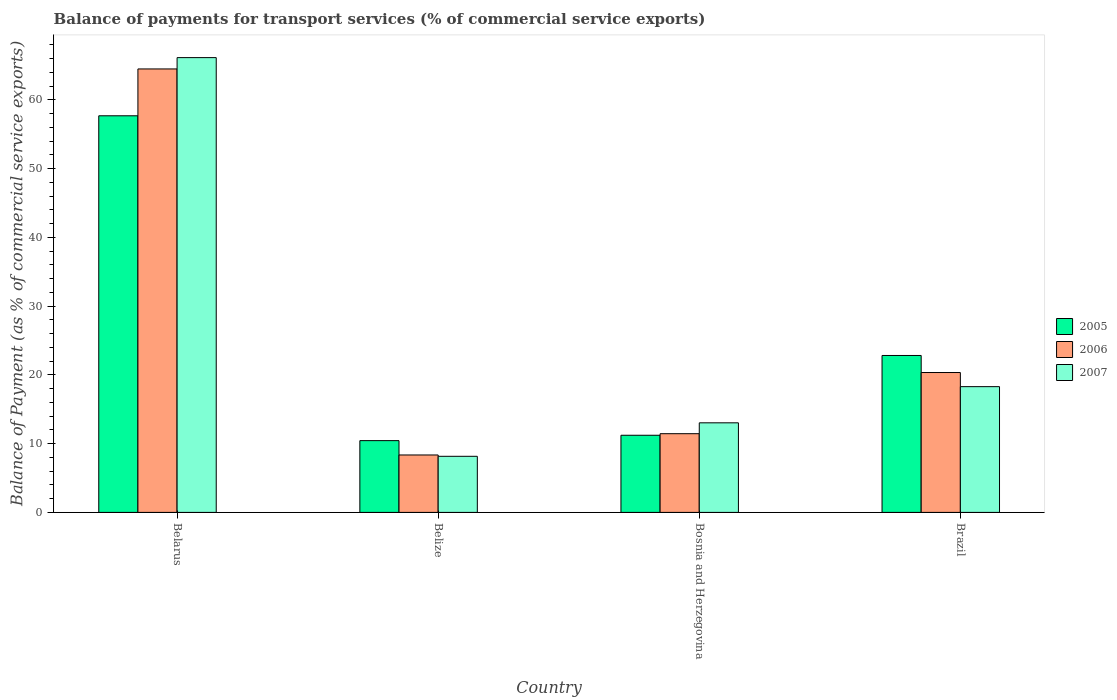How many different coloured bars are there?
Ensure brevity in your answer.  3. How many groups of bars are there?
Offer a very short reply. 4. Are the number of bars per tick equal to the number of legend labels?
Make the answer very short. Yes. Are the number of bars on each tick of the X-axis equal?
Your answer should be very brief. Yes. How many bars are there on the 4th tick from the left?
Your answer should be very brief. 3. What is the label of the 2nd group of bars from the left?
Make the answer very short. Belize. In how many cases, is the number of bars for a given country not equal to the number of legend labels?
Offer a terse response. 0. What is the balance of payments for transport services in 2007 in Belarus?
Offer a terse response. 66.15. Across all countries, what is the maximum balance of payments for transport services in 2007?
Provide a short and direct response. 66.15. Across all countries, what is the minimum balance of payments for transport services in 2005?
Provide a short and direct response. 10.44. In which country was the balance of payments for transport services in 2007 maximum?
Offer a terse response. Belarus. In which country was the balance of payments for transport services in 2007 minimum?
Offer a very short reply. Belize. What is the total balance of payments for transport services in 2005 in the graph?
Give a very brief answer. 102.18. What is the difference between the balance of payments for transport services in 2007 in Belarus and that in Brazil?
Your answer should be compact. 47.86. What is the difference between the balance of payments for transport services in 2007 in Bosnia and Herzegovina and the balance of payments for transport services in 2005 in Belarus?
Your answer should be compact. -44.66. What is the average balance of payments for transport services in 2006 per country?
Make the answer very short. 26.16. What is the difference between the balance of payments for transport services of/in 2007 and balance of payments for transport services of/in 2005 in Belize?
Your answer should be compact. -2.28. What is the ratio of the balance of payments for transport services in 2006 in Belarus to that in Bosnia and Herzegovina?
Offer a terse response. 5.63. What is the difference between the highest and the second highest balance of payments for transport services in 2005?
Offer a very short reply. 46.47. What is the difference between the highest and the lowest balance of payments for transport services in 2007?
Keep it short and to the point. 58. Is the sum of the balance of payments for transport services in 2006 in Bosnia and Herzegovina and Brazil greater than the maximum balance of payments for transport services in 2007 across all countries?
Provide a short and direct response. No. What does the 3rd bar from the left in Brazil represents?
Ensure brevity in your answer.  2007. How many bars are there?
Offer a very short reply. 12. Are all the bars in the graph horizontal?
Provide a succinct answer. No. How many countries are there in the graph?
Your answer should be very brief. 4. What is the difference between two consecutive major ticks on the Y-axis?
Provide a short and direct response. 10. Does the graph contain any zero values?
Offer a terse response. No. Does the graph contain grids?
Offer a very short reply. No. How many legend labels are there?
Give a very brief answer. 3. How are the legend labels stacked?
Your answer should be very brief. Vertical. What is the title of the graph?
Provide a short and direct response. Balance of payments for transport services (% of commercial service exports). Does "1978" appear as one of the legend labels in the graph?
Provide a succinct answer. No. What is the label or title of the Y-axis?
Give a very brief answer. Balance of Payment (as % of commercial service exports). What is the Balance of Payment (as % of commercial service exports) of 2005 in Belarus?
Give a very brief answer. 57.69. What is the Balance of Payment (as % of commercial service exports) of 2006 in Belarus?
Keep it short and to the point. 64.51. What is the Balance of Payment (as % of commercial service exports) in 2007 in Belarus?
Give a very brief answer. 66.15. What is the Balance of Payment (as % of commercial service exports) of 2005 in Belize?
Make the answer very short. 10.44. What is the Balance of Payment (as % of commercial service exports) of 2006 in Belize?
Keep it short and to the point. 8.35. What is the Balance of Payment (as % of commercial service exports) in 2007 in Belize?
Keep it short and to the point. 8.16. What is the Balance of Payment (as % of commercial service exports) in 2005 in Bosnia and Herzegovina?
Make the answer very short. 11.22. What is the Balance of Payment (as % of commercial service exports) in 2006 in Bosnia and Herzegovina?
Give a very brief answer. 11.45. What is the Balance of Payment (as % of commercial service exports) of 2007 in Bosnia and Herzegovina?
Ensure brevity in your answer.  13.03. What is the Balance of Payment (as % of commercial service exports) in 2005 in Brazil?
Provide a short and direct response. 22.83. What is the Balance of Payment (as % of commercial service exports) of 2006 in Brazil?
Give a very brief answer. 20.35. What is the Balance of Payment (as % of commercial service exports) of 2007 in Brazil?
Your answer should be very brief. 18.29. Across all countries, what is the maximum Balance of Payment (as % of commercial service exports) of 2005?
Your answer should be very brief. 57.69. Across all countries, what is the maximum Balance of Payment (as % of commercial service exports) in 2006?
Provide a short and direct response. 64.51. Across all countries, what is the maximum Balance of Payment (as % of commercial service exports) in 2007?
Your answer should be compact. 66.15. Across all countries, what is the minimum Balance of Payment (as % of commercial service exports) in 2005?
Offer a terse response. 10.44. Across all countries, what is the minimum Balance of Payment (as % of commercial service exports) of 2006?
Your answer should be very brief. 8.35. Across all countries, what is the minimum Balance of Payment (as % of commercial service exports) in 2007?
Give a very brief answer. 8.16. What is the total Balance of Payment (as % of commercial service exports) of 2005 in the graph?
Your response must be concise. 102.18. What is the total Balance of Payment (as % of commercial service exports) of 2006 in the graph?
Your answer should be very brief. 104.65. What is the total Balance of Payment (as % of commercial service exports) in 2007 in the graph?
Offer a very short reply. 105.63. What is the difference between the Balance of Payment (as % of commercial service exports) of 2005 in Belarus and that in Belize?
Your answer should be compact. 47.25. What is the difference between the Balance of Payment (as % of commercial service exports) in 2006 in Belarus and that in Belize?
Your answer should be very brief. 56.15. What is the difference between the Balance of Payment (as % of commercial service exports) of 2007 in Belarus and that in Belize?
Make the answer very short. 58. What is the difference between the Balance of Payment (as % of commercial service exports) in 2005 in Belarus and that in Bosnia and Herzegovina?
Provide a succinct answer. 46.47. What is the difference between the Balance of Payment (as % of commercial service exports) in 2006 in Belarus and that in Bosnia and Herzegovina?
Your answer should be very brief. 53.06. What is the difference between the Balance of Payment (as % of commercial service exports) in 2007 in Belarus and that in Bosnia and Herzegovina?
Provide a short and direct response. 53.12. What is the difference between the Balance of Payment (as % of commercial service exports) in 2005 in Belarus and that in Brazil?
Ensure brevity in your answer.  34.86. What is the difference between the Balance of Payment (as % of commercial service exports) in 2006 in Belarus and that in Brazil?
Ensure brevity in your answer.  44.16. What is the difference between the Balance of Payment (as % of commercial service exports) of 2007 in Belarus and that in Brazil?
Provide a succinct answer. 47.86. What is the difference between the Balance of Payment (as % of commercial service exports) of 2005 in Belize and that in Bosnia and Herzegovina?
Your answer should be compact. -0.78. What is the difference between the Balance of Payment (as % of commercial service exports) in 2006 in Belize and that in Bosnia and Herzegovina?
Make the answer very short. -3.1. What is the difference between the Balance of Payment (as % of commercial service exports) of 2007 in Belize and that in Bosnia and Herzegovina?
Provide a succinct answer. -4.87. What is the difference between the Balance of Payment (as % of commercial service exports) of 2005 in Belize and that in Brazil?
Offer a terse response. -12.39. What is the difference between the Balance of Payment (as % of commercial service exports) of 2006 in Belize and that in Brazil?
Offer a very short reply. -11.99. What is the difference between the Balance of Payment (as % of commercial service exports) in 2007 in Belize and that in Brazil?
Ensure brevity in your answer.  -10.13. What is the difference between the Balance of Payment (as % of commercial service exports) of 2005 in Bosnia and Herzegovina and that in Brazil?
Give a very brief answer. -11.6. What is the difference between the Balance of Payment (as % of commercial service exports) of 2006 in Bosnia and Herzegovina and that in Brazil?
Your answer should be compact. -8.9. What is the difference between the Balance of Payment (as % of commercial service exports) in 2007 in Bosnia and Herzegovina and that in Brazil?
Offer a very short reply. -5.26. What is the difference between the Balance of Payment (as % of commercial service exports) in 2005 in Belarus and the Balance of Payment (as % of commercial service exports) in 2006 in Belize?
Keep it short and to the point. 49.34. What is the difference between the Balance of Payment (as % of commercial service exports) of 2005 in Belarus and the Balance of Payment (as % of commercial service exports) of 2007 in Belize?
Provide a short and direct response. 49.53. What is the difference between the Balance of Payment (as % of commercial service exports) in 2006 in Belarus and the Balance of Payment (as % of commercial service exports) in 2007 in Belize?
Offer a very short reply. 56.35. What is the difference between the Balance of Payment (as % of commercial service exports) of 2005 in Belarus and the Balance of Payment (as % of commercial service exports) of 2006 in Bosnia and Herzegovina?
Your answer should be very brief. 46.24. What is the difference between the Balance of Payment (as % of commercial service exports) in 2005 in Belarus and the Balance of Payment (as % of commercial service exports) in 2007 in Bosnia and Herzegovina?
Your answer should be very brief. 44.66. What is the difference between the Balance of Payment (as % of commercial service exports) in 2006 in Belarus and the Balance of Payment (as % of commercial service exports) in 2007 in Bosnia and Herzegovina?
Your answer should be compact. 51.48. What is the difference between the Balance of Payment (as % of commercial service exports) in 2005 in Belarus and the Balance of Payment (as % of commercial service exports) in 2006 in Brazil?
Your answer should be very brief. 37.34. What is the difference between the Balance of Payment (as % of commercial service exports) in 2005 in Belarus and the Balance of Payment (as % of commercial service exports) in 2007 in Brazil?
Make the answer very short. 39.4. What is the difference between the Balance of Payment (as % of commercial service exports) of 2006 in Belarus and the Balance of Payment (as % of commercial service exports) of 2007 in Brazil?
Ensure brevity in your answer.  46.21. What is the difference between the Balance of Payment (as % of commercial service exports) of 2005 in Belize and the Balance of Payment (as % of commercial service exports) of 2006 in Bosnia and Herzegovina?
Keep it short and to the point. -1.01. What is the difference between the Balance of Payment (as % of commercial service exports) of 2005 in Belize and the Balance of Payment (as % of commercial service exports) of 2007 in Bosnia and Herzegovina?
Your answer should be very brief. -2.59. What is the difference between the Balance of Payment (as % of commercial service exports) in 2006 in Belize and the Balance of Payment (as % of commercial service exports) in 2007 in Bosnia and Herzegovina?
Provide a short and direct response. -4.68. What is the difference between the Balance of Payment (as % of commercial service exports) of 2005 in Belize and the Balance of Payment (as % of commercial service exports) of 2006 in Brazil?
Offer a terse response. -9.91. What is the difference between the Balance of Payment (as % of commercial service exports) in 2005 in Belize and the Balance of Payment (as % of commercial service exports) in 2007 in Brazil?
Your answer should be very brief. -7.85. What is the difference between the Balance of Payment (as % of commercial service exports) of 2006 in Belize and the Balance of Payment (as % of commercial service exports) of 2007 in Brazil?
Ensure brevity in your answer.  -9.94. What is the difference between the Balance of Payment (as % of commercial service exports) of 2005 in Bosnia and Herzegovina and the Balance of Payment (as % of commercial service exports) of 2006 in Brazil?
Give a very brief answer. -9.13. What is the difference between the Balance of Payment (as % of commercial service exports) in 2005 in Bosnia and Herzegovina and the Balance of Payment (as % of commercial service exports) in 2007 in Brazil?
Ensure brevity in your answer.  -7.07. What is the difference between the Balance of Payment (as % of commercial service exports) of 2006 in Bosnia and Herzegovina and the Balance of Payment (as % of commercial service exports) of 2007 in Brazil?
Make the answer very short. -6.84. What is the average Balance of Payment (as % of commercial service exports) of 2005 per country?
Provide a succinct answer. 25.54. What is the average Balance of Payment (as % of commercial service exports) in 2006 per country?
Provide a short and direct response. 26.16. What is the average Balance of Payment (as % of commercial service exports) of 2007 per country?
Provide a short and direct response. 26.41. What is the difference between the Balance of Payment (as % of commercial service exports) in 2005 and Balance of Payment (as % of commercial service exports) in 2006 in Belarus?
Provide a succinct answer. -6.81. What is the difference between the Balance of Payment (as % of commercial service exports) of 2005 and Balance of Payment (as % of commercial service exports) of 2007 in Belarus?
Provide a succinct answer. -8.46. What is the difference between the Balance of Payment (as % of commercial service exports) of 2006 and Balance of Payment (as % of commercial service exports) of 2007 in Belarus?
Provide a succinct answer. -1.65. What is the difference between the Balance of Payment (as % of commercial service exports) in 2005 and Balance of Payment (as % of commercial service exports) in 2006 in Belize?
Provide a short and direct response. 2.09. What is the difference between the Balance of Payment (as % of commercial service exports) in 2005 and Balance of Payment (as % of commercial service exports) in 2007 in Belize?
Your answer should be very brief. 2.28. What is the difference between the Balance of Payment (as % of commercial service exports) of 2006 and Balance of Payment (as % of commercial service exports) of 2007 in Belize?
Offer a very short reply. 0.19. What is the difference between the Balance of Payment (as % of commercial service exports) in 2005 and Balance of Payment (as % of commercial service exports) in 2006 in Bosnia and Herzegovina?
Your response must be concise. -0.23. What is the difference between the Balance of Payment (as % of commercial service exports) in 2005 and Balance of Payment (as % of commercial service exports) in 2007 in Bosnia and Herzegovina?
Offer a very short reply. -1.81. What is the difference between the Balance of Payment (as % of commercial service exports) of 2006 and Balance of Payment (as % of commercial service exports) of 2007 in Bosnia and Herzegovina?
Your answer should be compact. -1.58. What is the difference between the Balance of Payment (as % of commercial service exports) of 2005 and Balance of Payment (as % of commercial service exports) of 2006 in Brazil?
Provide a short and direct response. 2.48. What is the difference between the Balance of Payment (as % of commercial service exports) in 2005 and Balance of Payment (as % of commercial service exports) in 2007 in Brazil?
Provide a succinct answer. 4.54. What is the difference between the Balance of Payment (as % of commercial service exports) of 2006 and Balance of Payment (as % of commercial service exports) of 2007 in Brazil?
Your answer should be compact. 2.06. What is the ratio of the Balance of Payment (as % of commercial service exports) in 2005 in Belarus to that in Belize?
Keep it short and to the point. 5.53. What is the ratio of the Balance of Payment (as % of commercial service exports) of 2006 in Belarus to that in Belize?
Give a very brief answer. 7.72. What is the ratio of the Balance of Payment (as % of commercial service exports) in 2007 in Belarus to that in Belize?
Give a very brief answer. 8.11. What is the ratio of the Balance of Payment (as % of commercial service exports) of 2005 in Belarus to that in Bosnia and Herzegovina?
Your answer should be very brief. 5.14. What is the ratio of the Balance of Payment (as % of commercial service exports) of 2006 in Belarus to that in Bosnia and Herzegovina?
Your response must be concise. 5.63. What is the ratio of the Balance of Payment (as % of commercial service exports) of 2007 in Belarus to that in Bosnia and Herzegovina?
Offer a very short reply. 5.08. What is the ratio of the Balance of Payment (as % of commercial service exports) in 2005 in Belarus to that in Brazil?
Provide a short and direct response. 2.53. What is the ratio of the Balance of Payment (as % of commercial service exports) of 2006 in Belarus to that in Brazil?
Offer a very short reply. 3.17. What is the ratio of the Balance of Payment (as % of commercial service exports) of 2007 in Belarus to that in Brazil?
Your response must be concise. 3.62. What is the ratio of the Balance of Payment (as % of commercial service exports) in 2005 in Belize to that in Bosnia and Herzegovina?
Give a very brief answer. 0.93. What is the ratio of the Balance of Payment (as % of commercial service exports) of 2006 in Belize to that in Bosnia and Herzegovina?
Make the answer very short. 0.73. What is the ratio of the Balance of Payment (as % of commercial service exports) in 2007 in Belize to that in Bosnia and Herzegovina?
Make the answer very short. 0.63. What is the ratio of the Balance of Payment (as % of commercial service exports) in 2005 in Belize to that in Brazil?
Keep it short and to the point. 0.46. What is the ratio of the Balance of Payment (as % of commercial service exports) of 2006 in Belize to that in Brazil?
Offer a very short reply. 0.41. What is the ratio of the Balance of Payment (as % of commercial service exports) of 2007 in Belize to that in Brazil?
Make the answer very short. 0.45. What is the ratio of the Balance of Payment (as % of commercial service exports) of 2005 in Bosnia and Herzegovina to that in Brazil?
Provide a short and direct response. 0.49. What is the ratio of the Balance of Payment (as % of commercial service exports) of 2006 in Bosnia and Herzegovina to that in Brazil?
Your answer should be very brief. 0.56. What is the ratio of the Balance of Payment (as % of commercial service exports) of 2007 in Bosnia and Herzegovina to that in Brazil?
Offer a terse response. 0.71. What is the difference between the highest and the second highest Balance of Payment (as % of commercial service exports) in 2005?
Offer a terse response. 34.86. What is the difference between the highest and the second highest Balance of Payment (as % of commercial service exports) of 2006?
Provide a short and direct response. 44.16. What is the difference between the highest and the second highest Balance of Payment (as % of commercial service exports) in 2007?
Offer a terse response. 47.86. What is the difference between the highest and the lowest Balance of Payment (as % of commercial service exports) in 2005?
Provide a succinct answer. 47.25. What is the difference between the highest and the lowest Balance of Payment (as % of commercial service exports) of 2006?
Provide a short and direct response. 56.15. What is the difference between the highest and the lowest Balance of Payment (as % of commercial service exports) of 2007?
Give a very brief answer. 58. 